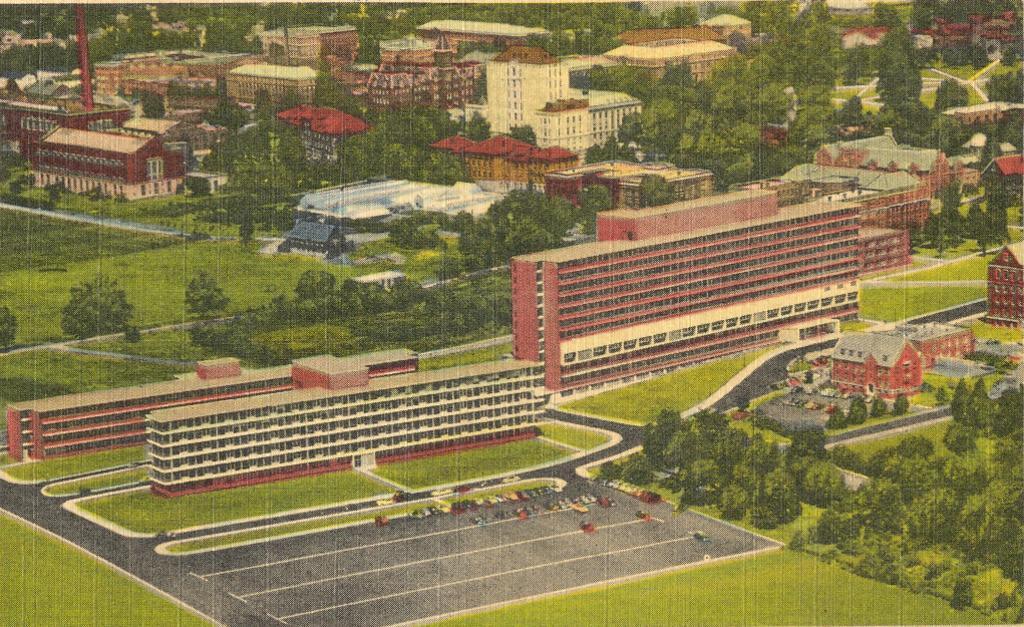Could you give a brief overview of what you see in this image? In this picture we can see buildings, trees, roads, grass and some objects. 